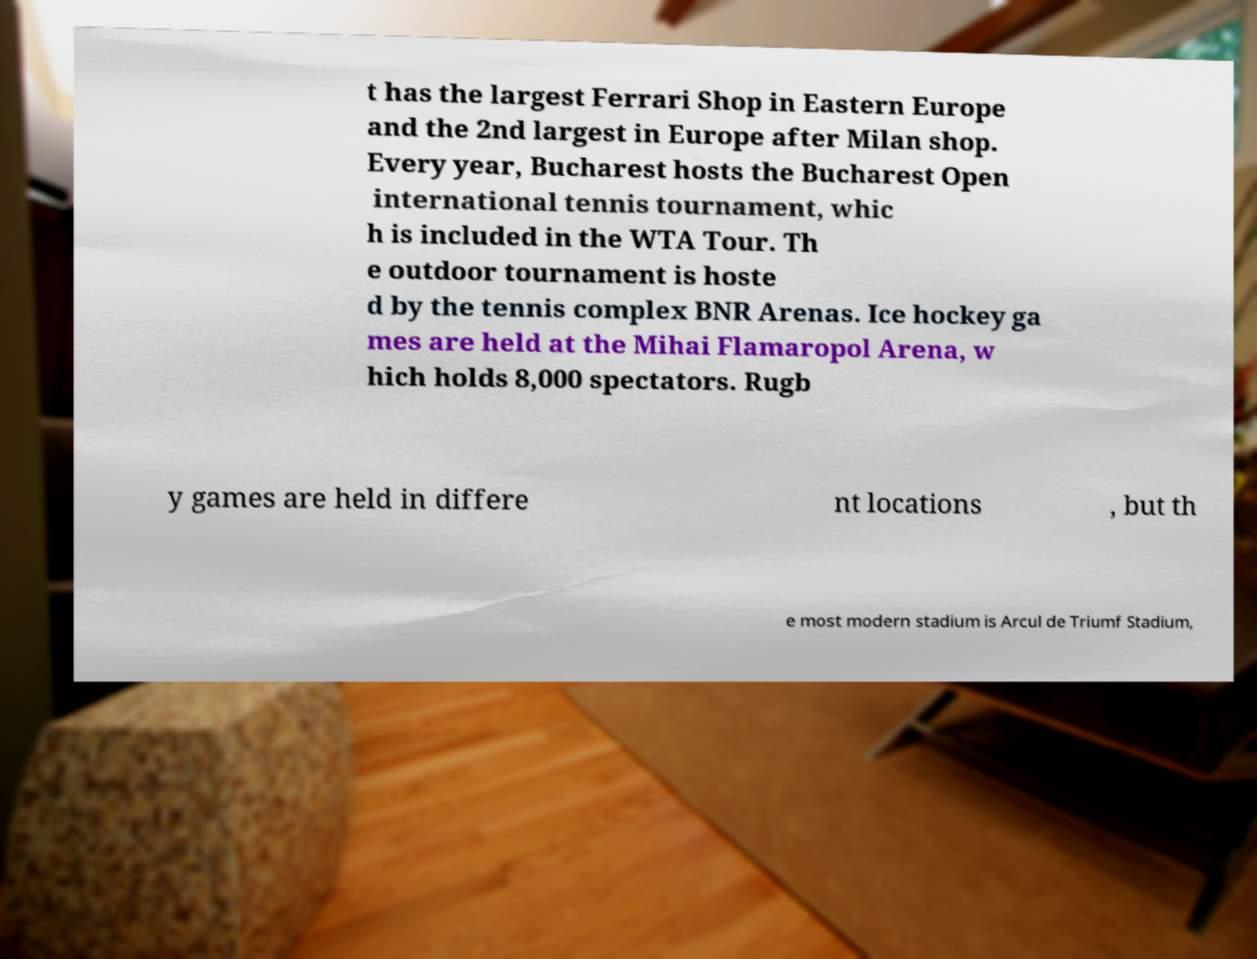Can you read and provide the text displayed in the image?This photo seems to have some interesting text. Can you extract and type it out for me? t has the largest Ferrari Shop in Eastern Europe and the 2nd largest in Europe after Milan shop. Every year, Bucharest hosts the Bucharest Open international tennis tournament, whic h is included in the WTA Tour. Th e outdoor tournament is hoste d by the tennis complex BNR Arenas. Ice hockey ga mes are held at the Mihai Flamaropol Arena, w hich holds 8,000 spectators. Rugb y games are held in differe nt locations , but th e most modern stadium is Arcul de Triumf Stadium, 